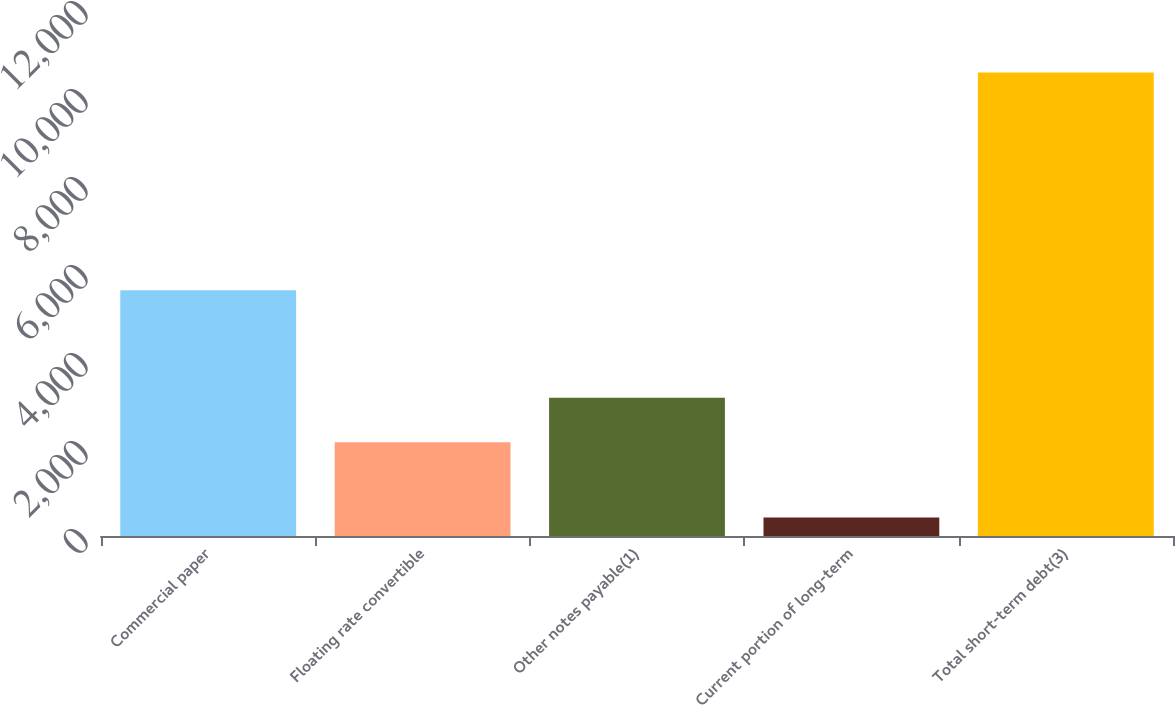Convert chart to OTSL. <chart><loc_0><loc_0><loc_500><loc_500><bar_chart><fcel>Commercial paper<fcel>Floating rate convertible<fcel>Other notes payable(1)<fcel>Current portion of long-term<fcel>Total short-term debt(3)<nl><fcel>5586<fcel>2131<fcel>3142.4<fcel>421<fcel>10535<nl></chart> 